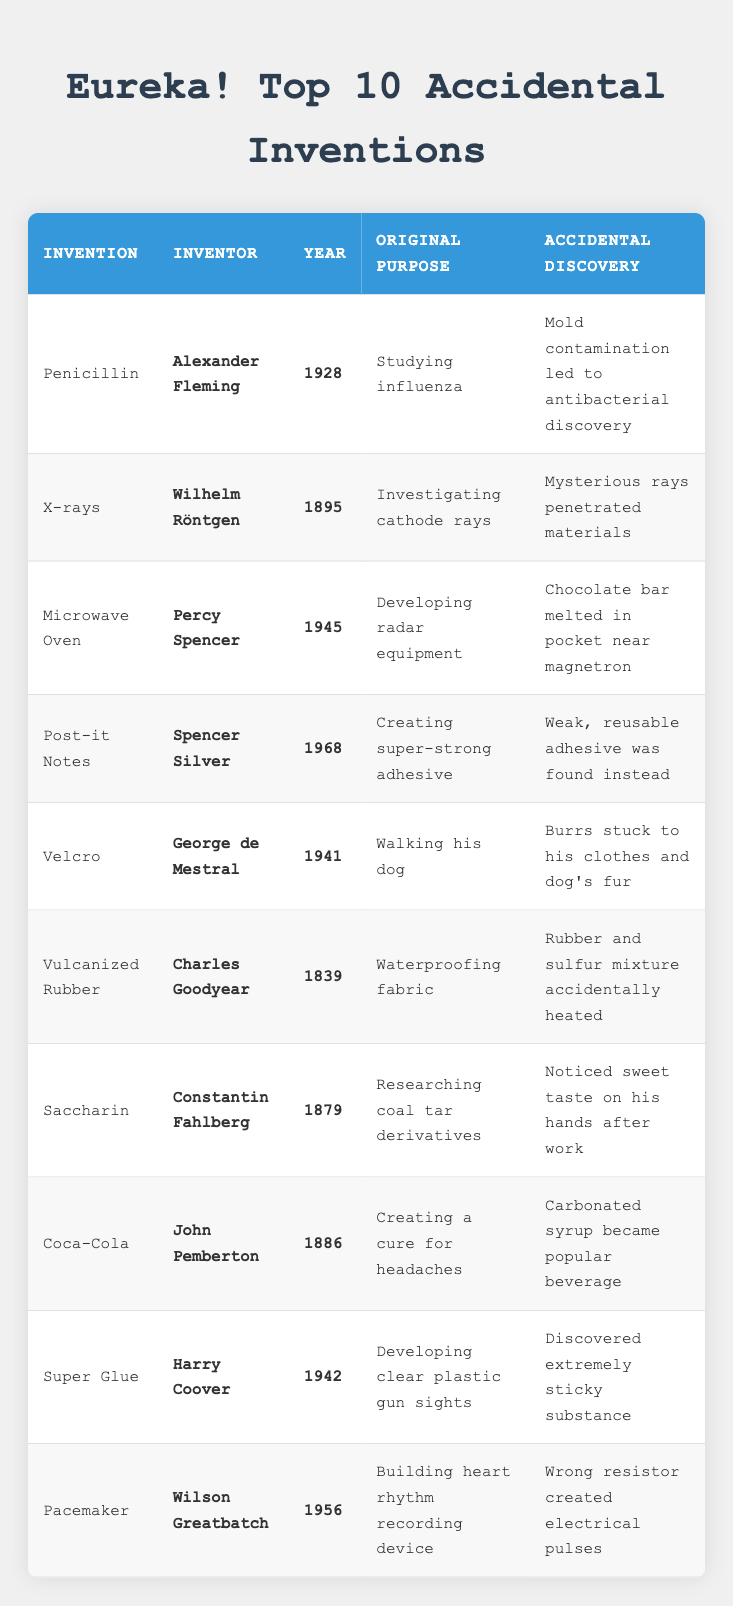What invention was discovered by accident while studying influenza? The table lists Penicillin, invented by Alexander Fleming in 1928, as a result of studying influenza, where mold contamination led to its discovery.
Answer: Penicillin Who invented the microwave oven and what was its original purpose? The table shows that Percy Spencer invented the microwave oven in 1945, originally meant for developing radar equipment.
Answer: Percy Spencer; radar equipment How many inventions were discovered in the 1940s? Based on the table, there are three inventions from the 1940s: the microwave oven (1945), Velcro (1941), and Super Glue (1942). Counting them gives a total of 3 inventions.
Answer: 3 Is it true that Coca-Cola was initially created as a cure for headaches? The table states that Coca-Cola, invented by John Pemberton in 1886, was indeed created to be a cure for headaches, confirming that the statement is true.
Answer: Yes Which accidental invention involves a sweet taste being noticed on hands? The table indicates that Saccharin, invented by Constantin Fahlberg in 1879, was discovered after he noticed a sweet taste on his hands after research work.
Answer: Saccharin What year was vulcanized rubber invented, and what was its accidental discovery? From the table, vulcanized rubber was invented by Charles Goodyear in 1839, and the accidental discovery was due to the heating of a rubber and sulfur mixture.
Answer: 1839; heating of rubber and sulfur Which inventor is associated with three inventions in the table, and what are they? By looking through the table, we see that no inventor is directly tied to three inventions listed. Each inventor is tied to just one invention in the table.
Answer: None What is the relationship between X-rays and investigating cathode rays? The table specifies that X-rays, discovered by Wilhelm Röntgen in 1895, were an accidental discovery while he was investigating cathode rays, indicating a direct relationship between the two.
Answer: Direct relationship Can we conclude that all the inventions listed were discovered after the year 1800? A quick review of the table reveals that four inventions were discovered before 1800: vulcanized rubber (1839) and Saccharin (1879). Therefore, the statement is false.
Answer: No 